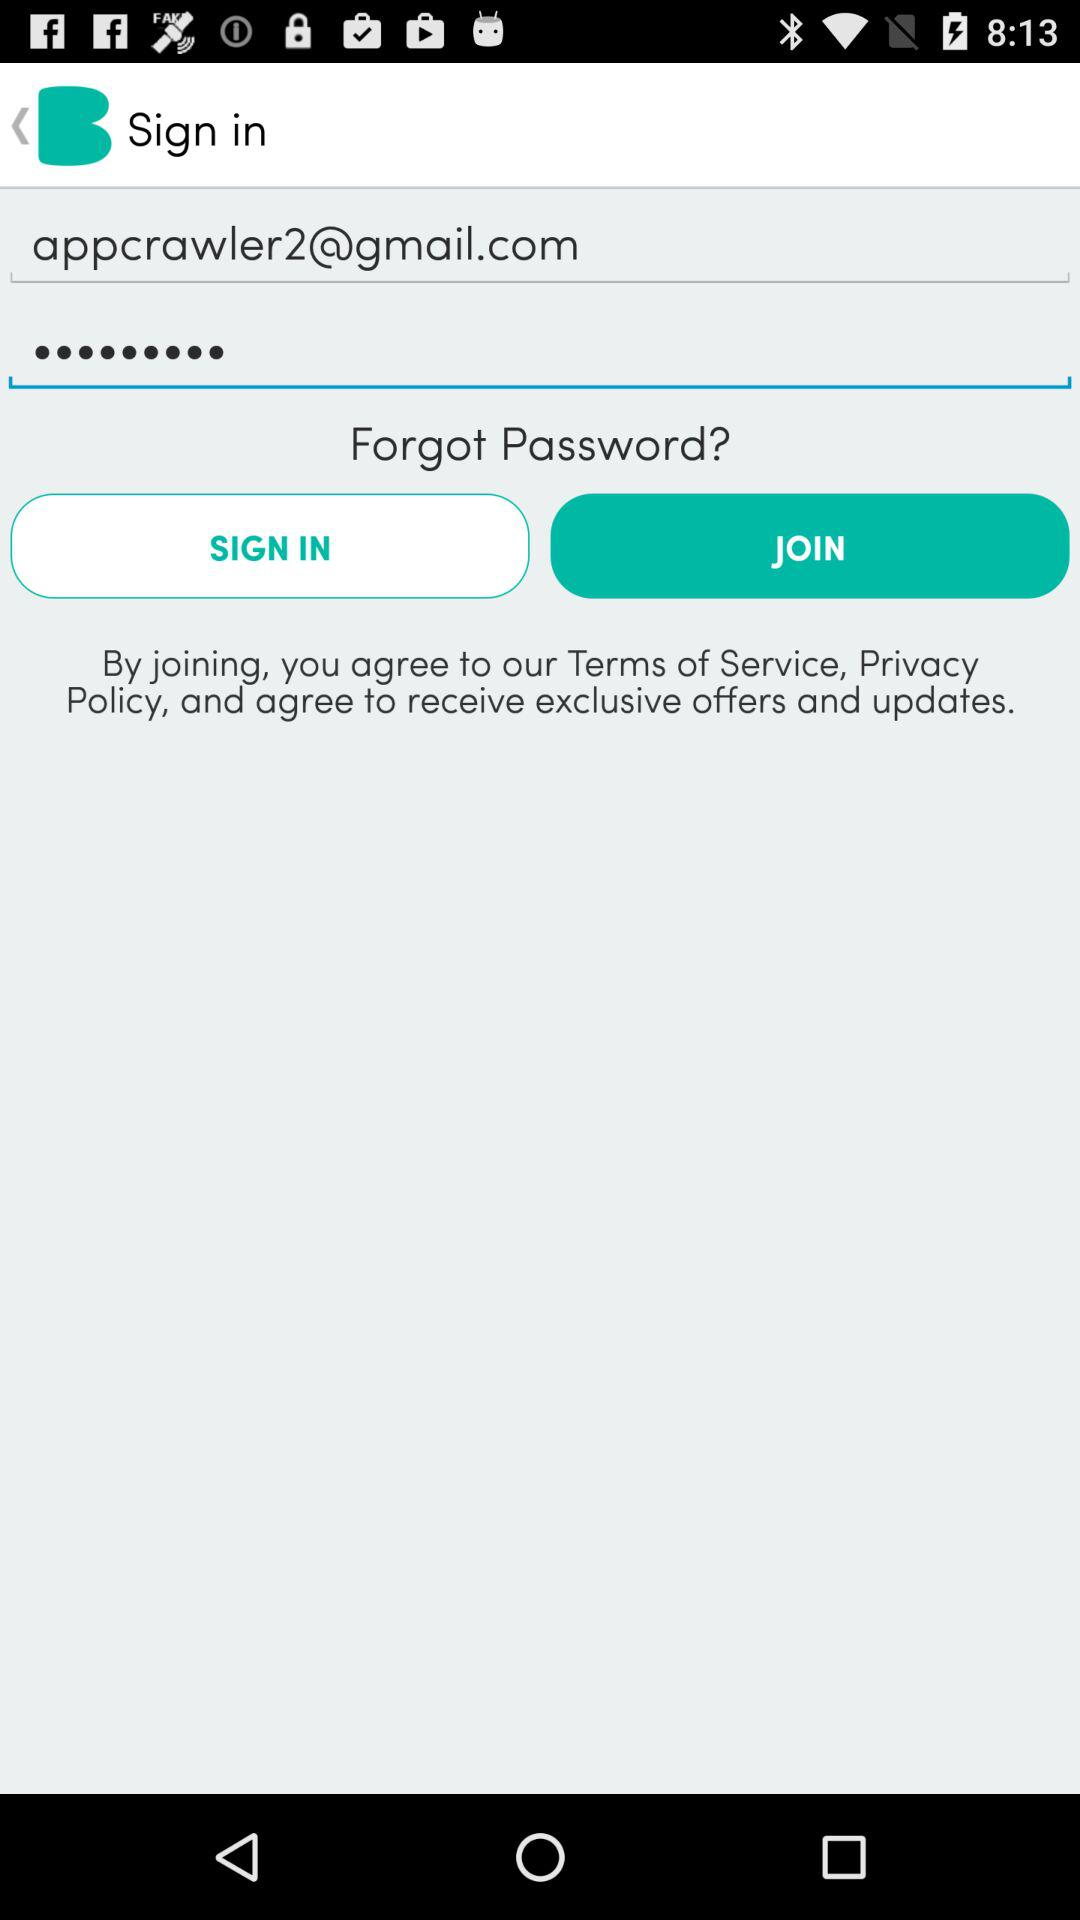What's the sign-in account email? The sign-in account email is appcrawler2@gmail.com. 